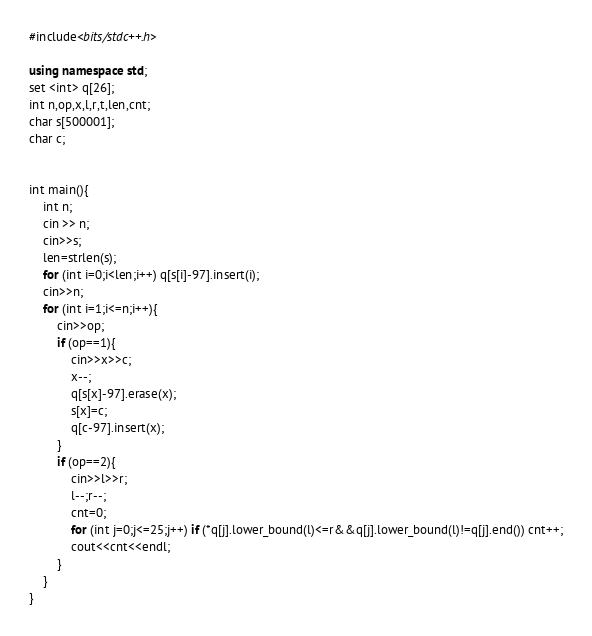<code> <loc_0><loc_0><loc_500><loc_500><_C++_>#include<bits/stdc++.h>
 
using namespace std;
set <int> q[26];
int n,op,x,l,r,t,len,cnt;
char s[500001]; 
char c;
 
 
int main(){
	int n;
	cin >> n;
	cin>>s;
	len=strlen(s);
	for (int i=0;i<len;i++) q[s[i]-97].insert(i);
	cin>>n;
	for (int i=1;i<=n;i++){
		cin>>op;
		if (op==1){
			cin>>x>>c;
			x--;
			q[s[x]-97].erase(x);
			s[x]=c;
			q[c-97].insert(x);
		}
		if (op==2){
			cin>>l>>r;
			l--;r--;
			cnt=0;
			for (int j=0;j<=25;j++) if (*q[j].lower_bound(l)<=r&&q[j].lower_bound(l)!=q[j].end()) cnt++;
			cout<<cnt<<endl;
		}
	}
}</code> 